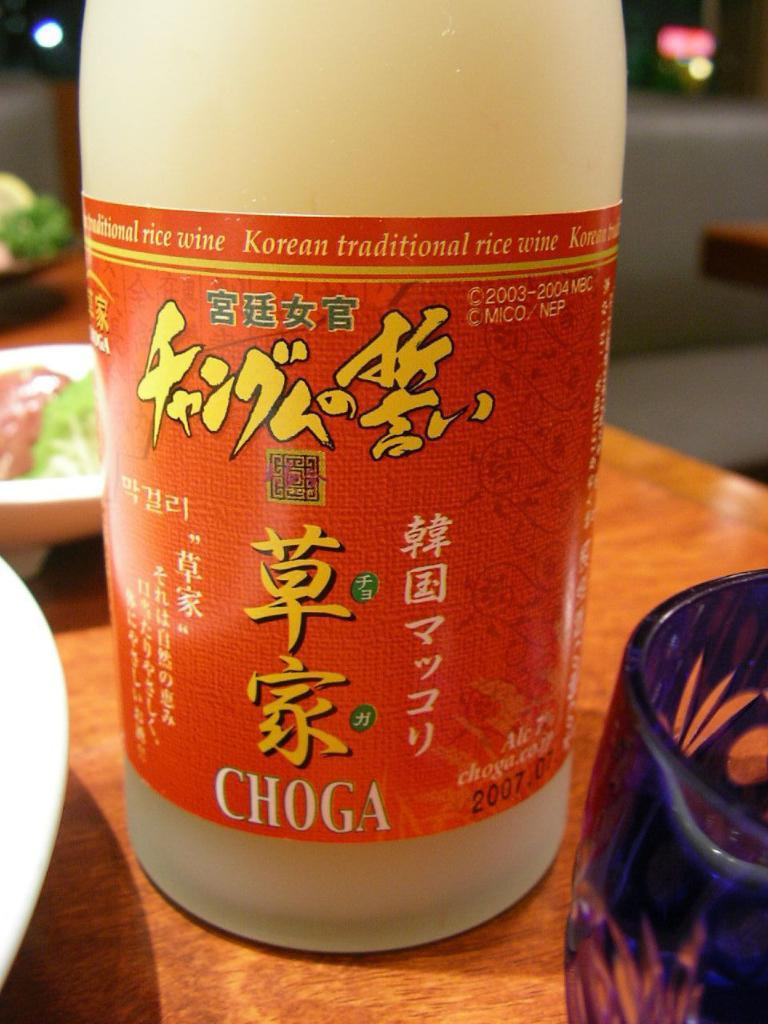Provide a one-sentence caption for the provided image. A bottle of Chinese Choga rice wine sitting at a dinner table. 